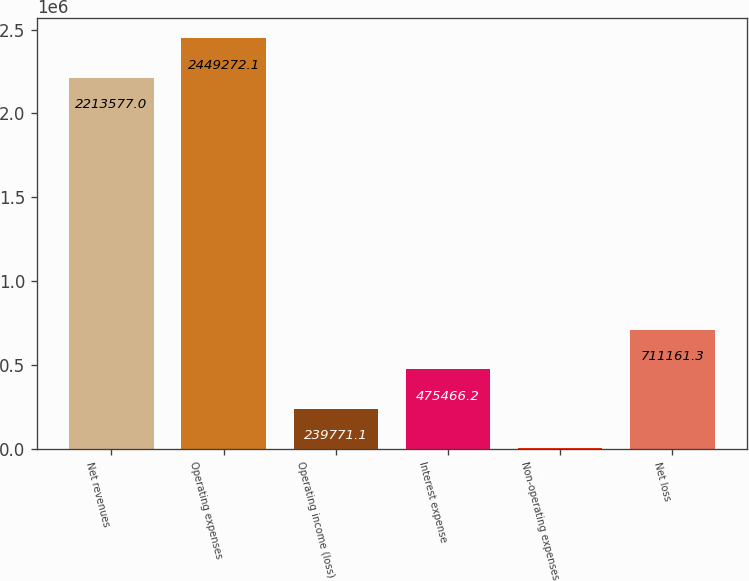Convert chart to OTSL. <chart><loc_0><loc_0><loc_500><loc_500><bar_chart><fcel>Net revenues<fcel>Operating expenses<fcel>Operating income (loss)<fcel>Interest expense<fcel>Non-operating expenses<fcel>Net loss<nl><fcel>2.21358e+06<fcel>2.44927e+06<fcel>239771<fcel>475466<fcel>4076<fcel>711161<nl></chart> 